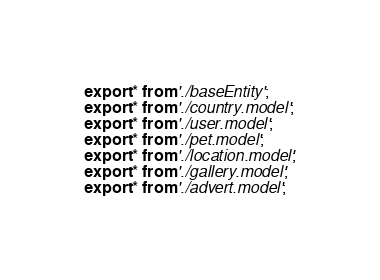<code> <loc_0><loc_0><loc_500><loc_500><_TypeScript_>export * from './baseEntity';
export * from './country.model';
export * from './user.model';
export * from './pet.model';
export * from './location.model';
export * from './gallery.model';
export * from './advert.model';
</code> 